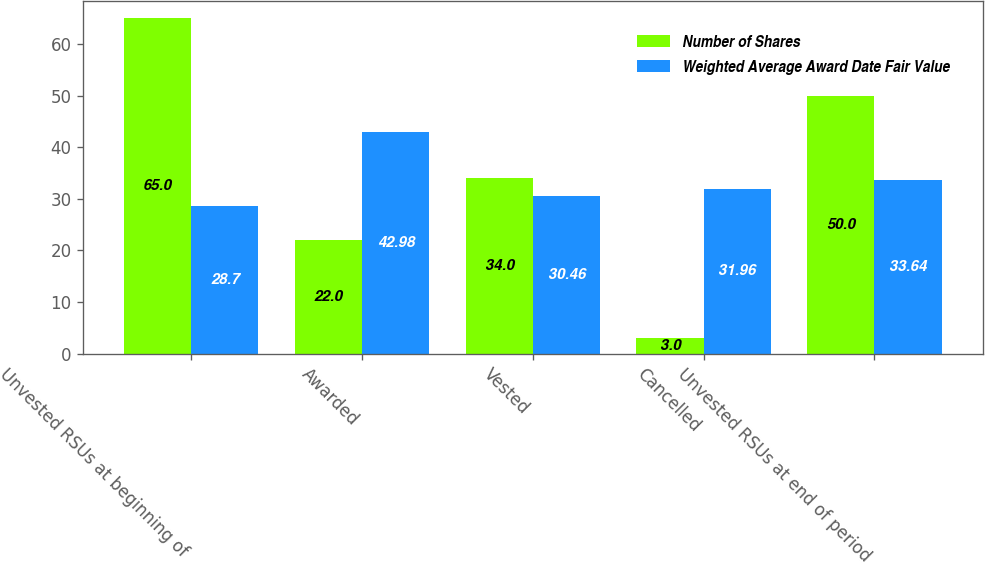Convert chart to OTSL. <chart><loc_0><loc_0><loc_500><loc_500><stacked_bar_chart><ecel><fcel>Unvested RSUs at beginning of<fcel>Awarded<fcel>Vested<fcel>Cancelled<fcel>Unvested RSUs at end of period<nl><fcel>Number of Shares<fcel>65<fcel>22<fcel>34<fcel>3<fcel>50<nl><fcel>Weighted Average Award Date Fair Value<fcel>28.7<fcel>42.98<fcel>30.46<fcel>31.96<fcel>33.64<nl></chart> 